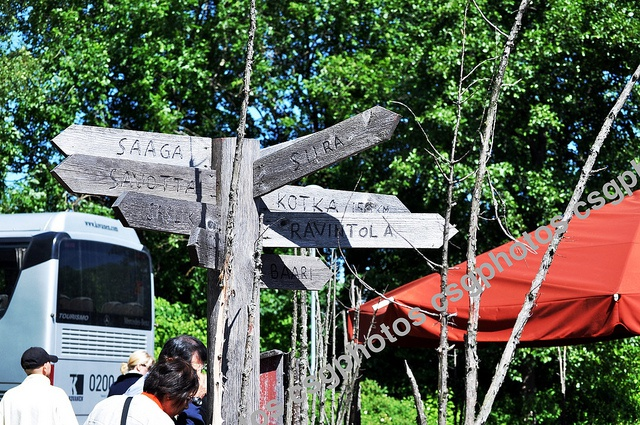Describe the objects in this image and their specific colors. I can see umbrella in black, salmon, darkgray, and brown tones, bus in black, lavender, and lightblue tones, people in black, white, gray, and maroon tones, people in black, white, and tan tones, and people in black, gray, blue, and lightgray tones in this image. 